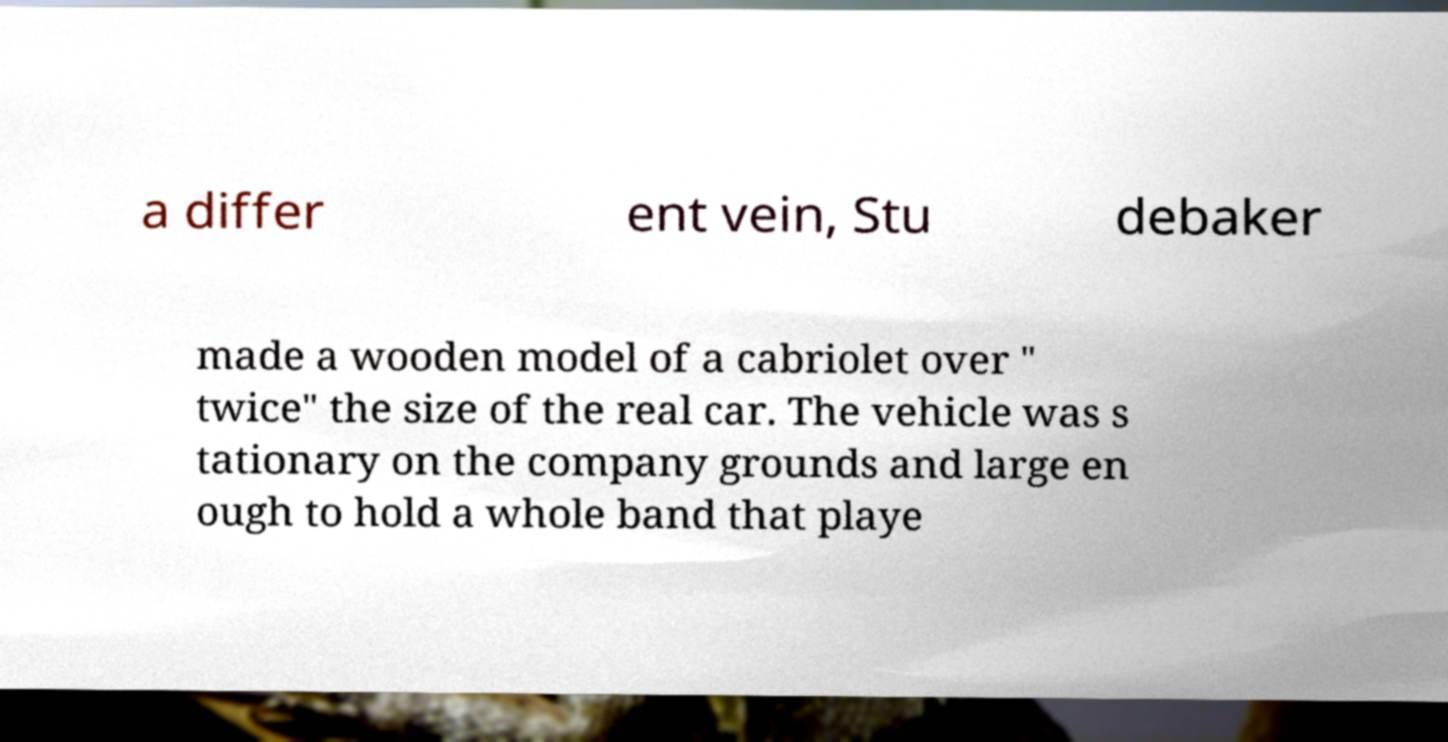There's text embedded in this image that I need extracted. Can you transcribe it verbatim? a differ ent vein, Stu debaker made a wooden model of a cabriolet over " twice" the size of the real car. The vehicle was s tationary on the company grounds and large en ough to hold a whole band that playe 